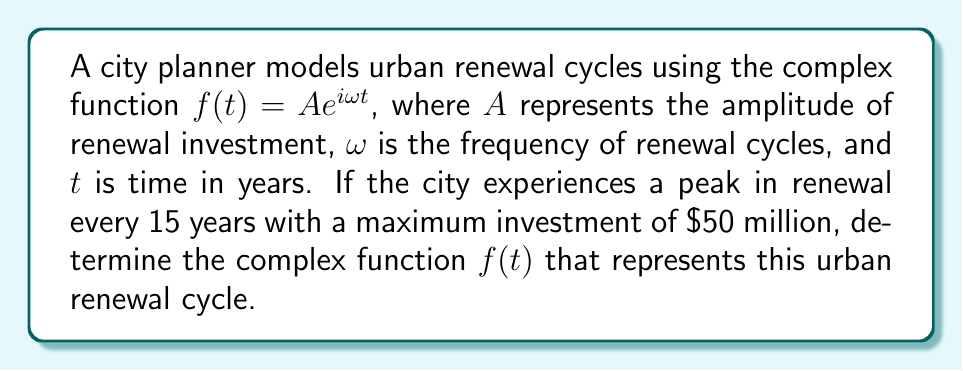Teach me how to tackle this problem. 1) First, we need to determine $\omega$. Given that the cycle repeats every 15 years:
   $$\omega = \frac{2\pi}{T} = \frac{2\pi}{15}$$

2) We're given that the maximum investment (amplitude) is $50 million, so $A = 50$.

3) The general form of the complex function is:
   $$f(t) = Ae^{i\omega t}$$

4) Substituting our values:
   $$f(t) = 50e^{i\frac{2\pi}{15}t}$$

5) This function represents a periodic cycle with:
   - Amplitude of $50 million
   - Period of 15 years
   - Angular frequency of $\frac{2\pi}{15}$ radians per year

6) The real part of this function, $50\cos(\frac{2\pi}{15}t)$, represents the actual investment over time, oscillating between -$50 million and $50 million.

7) The imaginary part, $50\sin(\frac{2\pi}{15}t)$, represents the rate of change of the investment.
Answer: $f(t) = 50e^{i\frac{2\pi}{15}t}$ 